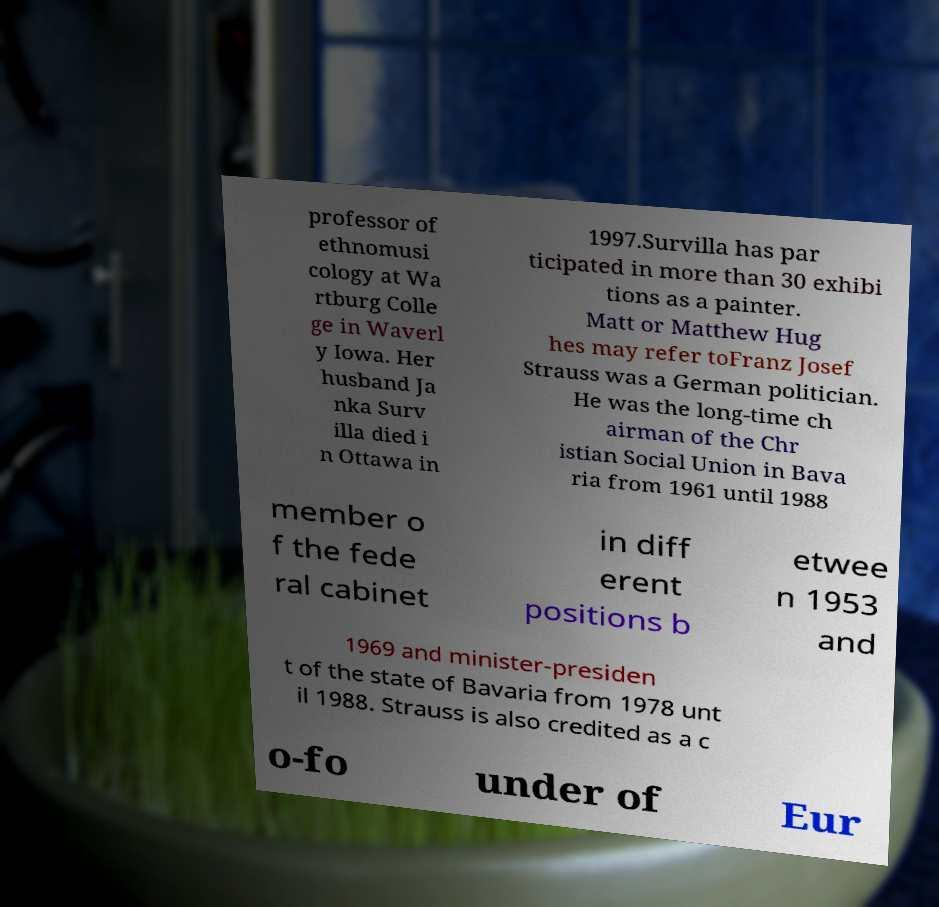There's text embedded in this image that I need extracted. Can you transcribe it verbatim? professor of ethnomusi cology at Wa rtburg Colle ge in Waverl y Iowa. Her husband Ja nka Surv illa died i n Ottawa in 1997.Survilla has par ticipated in more than 30 exhibi tions as a painter. Matt or Matthew Hug hes may refer toFranz Josef Strauss was a German politician. He was the long-time ch airman of the Chr istian Social Union in Bava ria from 1961 until 1988 member o f the fede ral cabinet in diff erent positions b etwee n 1953 and 1969 and minister-presiden t of the state of Bavaria from 1978 unt il 1988. Strauss is also credited as a c o-fo under of Eur 